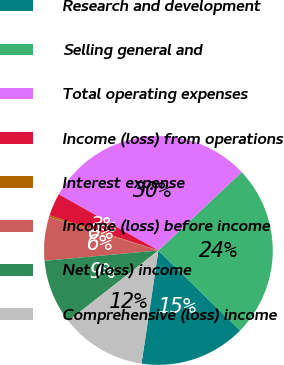<chart> <loc_0><loc_0><loc_500><loc_500><pie_chart><fcel>Research and development<fcel>Selling general and<fcel>Total operating expenses<fcel>Income (loss) from operations<fcel>Interest expense<fcel>Income (loss) before income<fcel>Net (loss) income<fcel>Comprehensive (loss) income<nl><fcel>15.03%<fcel>24.34%<fcel>29.81%<fcel>3.21%<fcel>0.25%<fcel>6.16%<fcel>9.12%<fcel>12.08%<nl></chart> 